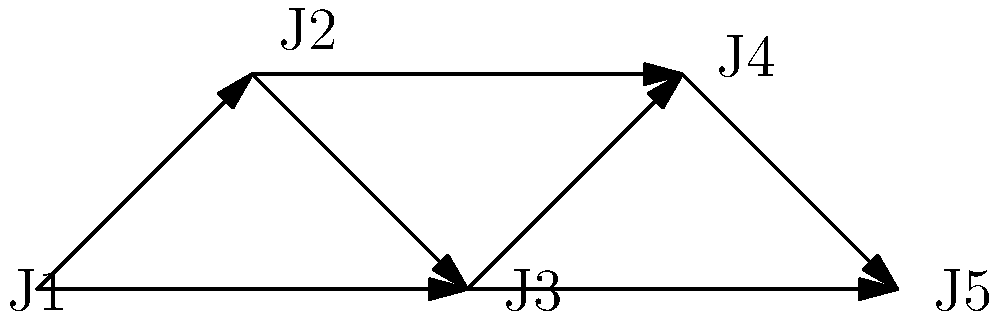In the given directed graph representing journal citations, where each node represents a journal and each directed edge represents a citation from one journal to another, what is the in-degree of journal J3? To find the in-degree of journal J3, we need to follow these steps:

1. Understand the concept: The in-degree of a vertex in a directed graph is the number of edges coming into that vertex.

2. Identify J3 in the graph: J3 is the middle node at the bottom of the graph.

3. Count the incoming edges to J3:
   a. There is an edge from J1 to J3
   b. There is an edge from J2 to J3

4. Sum up the total number of incoming edges: 2

Therefore, the in-degree of journal J3 is 2.
Answer: 2 